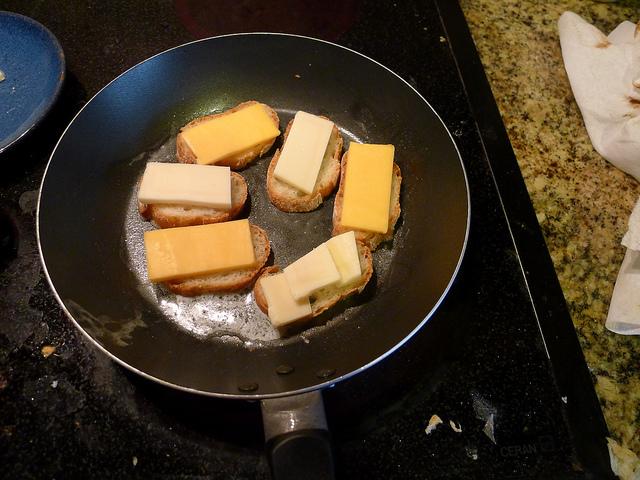What is in the pan?
Keep it brief. Bread and cheese. Is this cheese toast?
Concise answer only. Yes. How many pieces of bread are there?
Keep it brief. 6. 